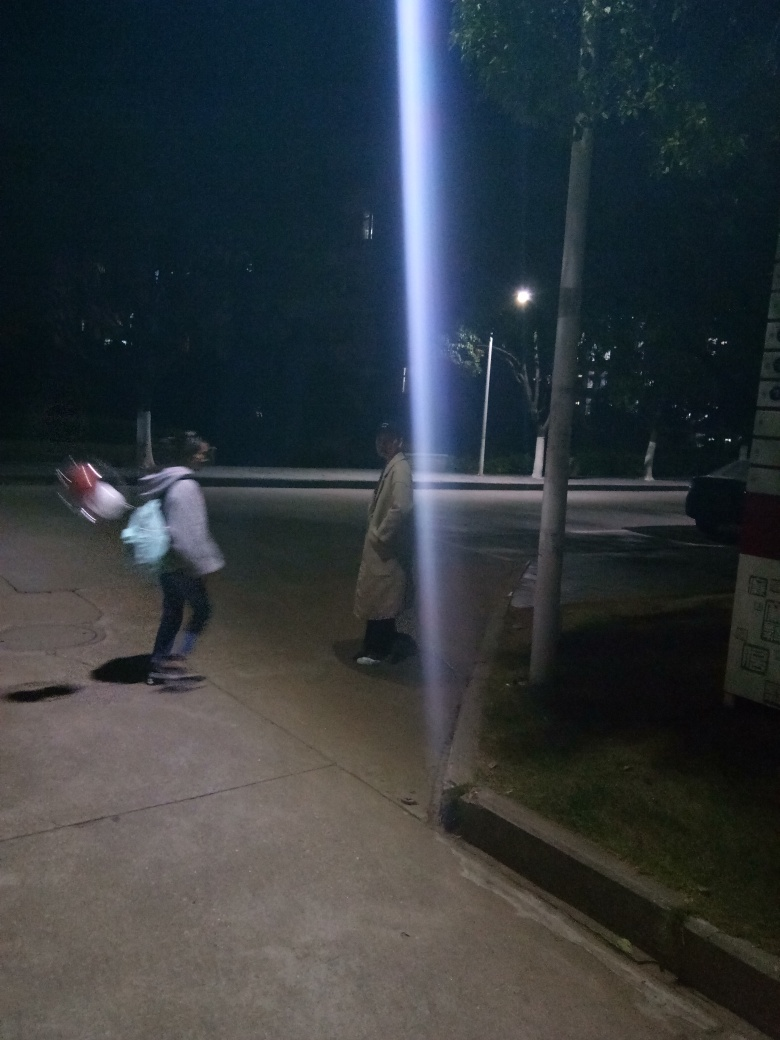Can you describe the atmosphere or mood perceived from this image? The image conveys a quiet and possibly solitary atmosphere. The presence of just a few individuals and the darkness of the night contribute to a feeling of solitude and calm. The light cutting through the darkness adds to the scene's ambience, creating a somewhat mysterious mood. 